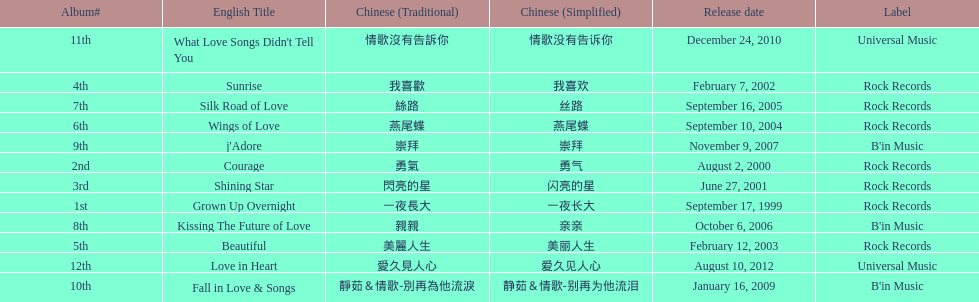Was the album beautiful released before the album love in heart? Yes. 